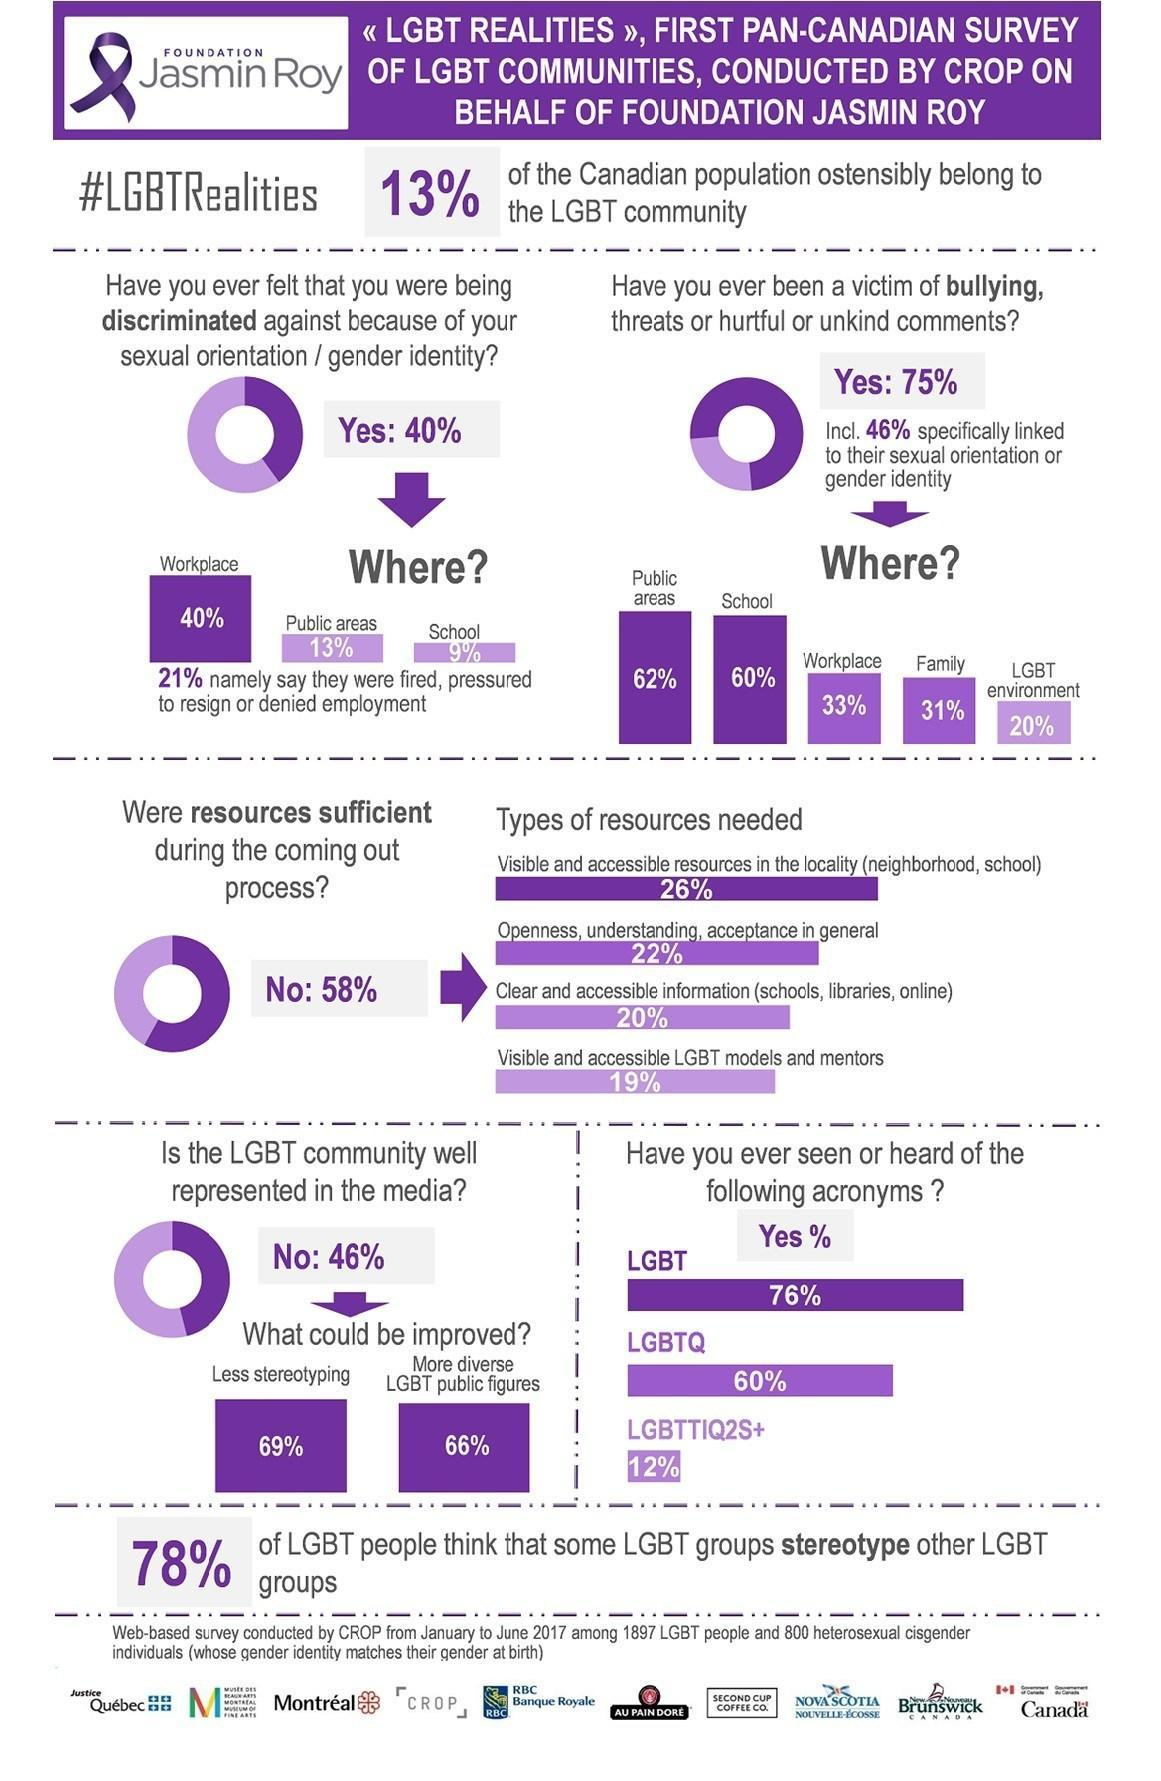where has 13% of the discrimination occured
Answer the question with a short phrase. public areas what should be the improvement in more diverse lgbt public figures 66% where was 60% of the bullying school how many agree that LGBT community is not well represented in media 46 how many found the resources insufficient during coming out process 58% where was 40% of the discrimination felt workplace 